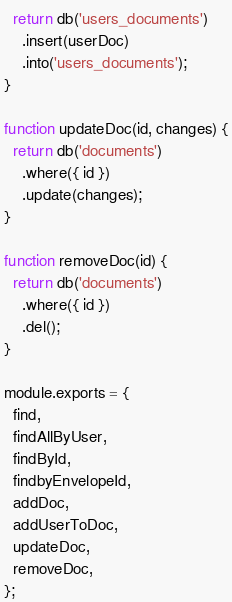Convert code to text. <code><loc_0><loc_0><loc_500><loc_500><_JavaScript_>  return db('users_documents')
    .insert(userDoc)
    .into('users_documents');
}

function updateDoc(id, changes) {
  return db('documents')
    .where({ id })
    .update(changes);
}

function removeDoc(id) {
  return db('documents')
    .where({ id })
    .del();
}

module.exports = {
  find,
  findAllByUser,
  findById,
  findbyEnvelopeId,
  addDoc,
  addUserToDoc,
  updateDoc,
  removeDoc,
};
</code> 